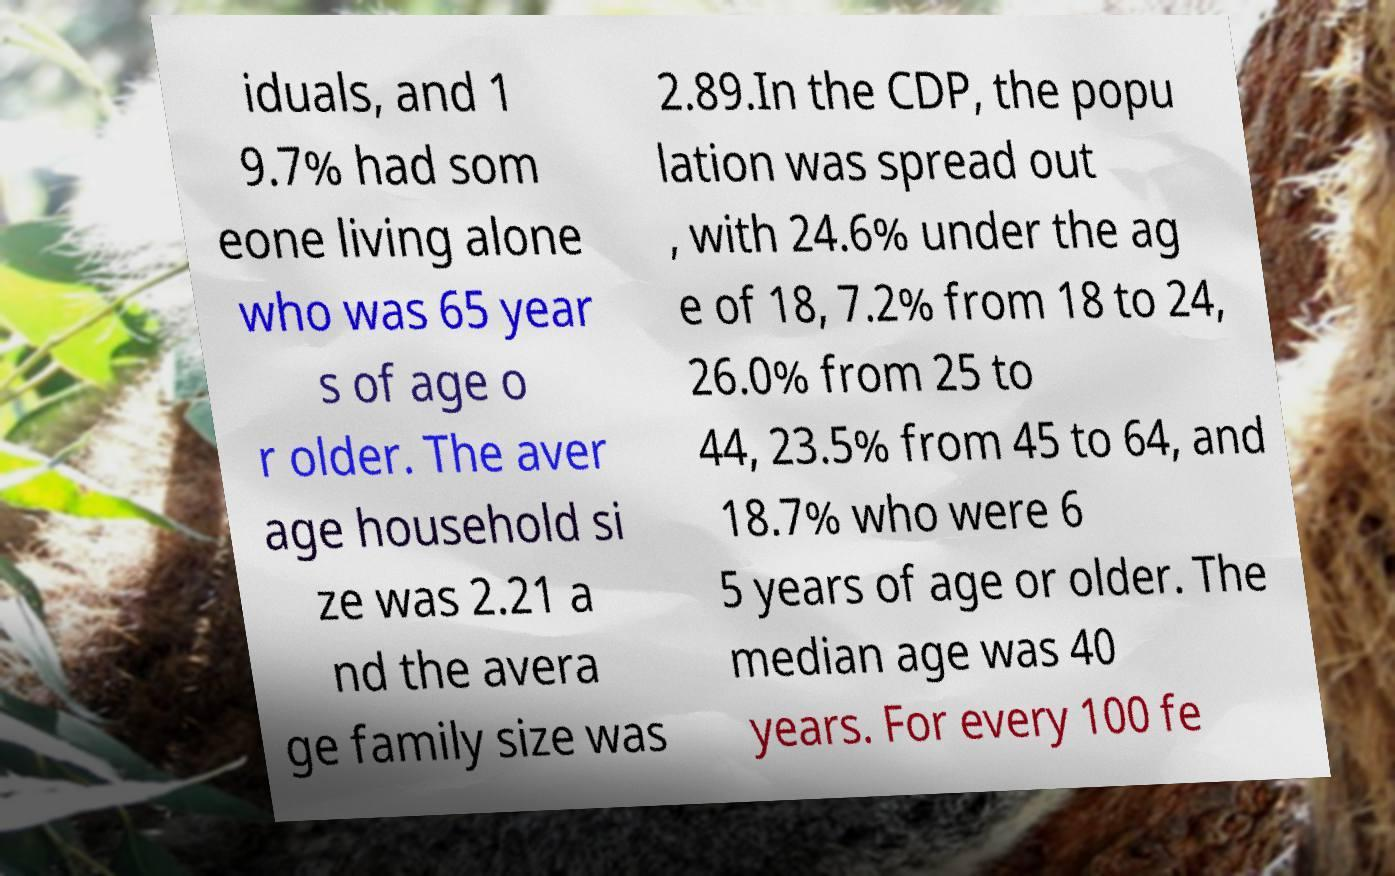Can you read and provide the text displayed in the image?This photo seems to have some interesting text. Can you extract and type it out for me? iduals, and 1 9.7% had som eone living alone who was 65 year s of age o r older. The aver age household si ze was 2.21 a nd the avera ge family size was 2.89.In the CDP, the popu lation was spread out , with 24.6% under the ag e of 18, 7.2% from 18 to 24, 26.0% from 25 to 44, 23.5% from 45 to 64, and 18.7% who were 6 5 years of age or older. The median age was 40 years. For every 100 fe 